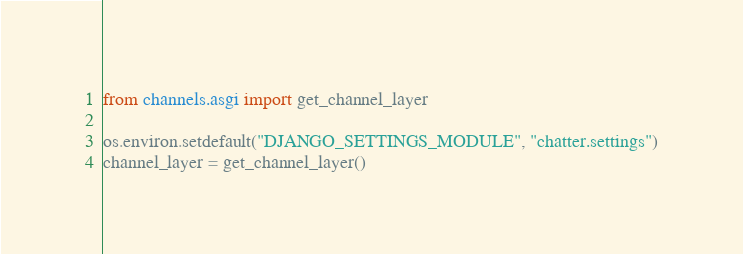Convert code to text. <code><loc_0><loc_0><loc_500><loc_500><_Python_>
from channels.asgi import get_channel_layer

os.environ.setdefault("DJANGO_SETTINGS_MODULE", "chatter.settings")
channel_layer = get_channel_layer()
</code> 